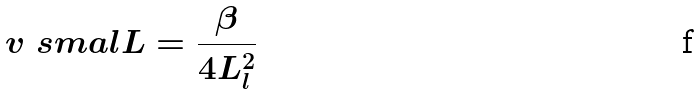<formula> <loc_0><loc_0><loc_500><loc_500>v _ { \ } s m a l L = \frac { \beta } { 4 L _ { l } ^ { 2 } }</formula> 